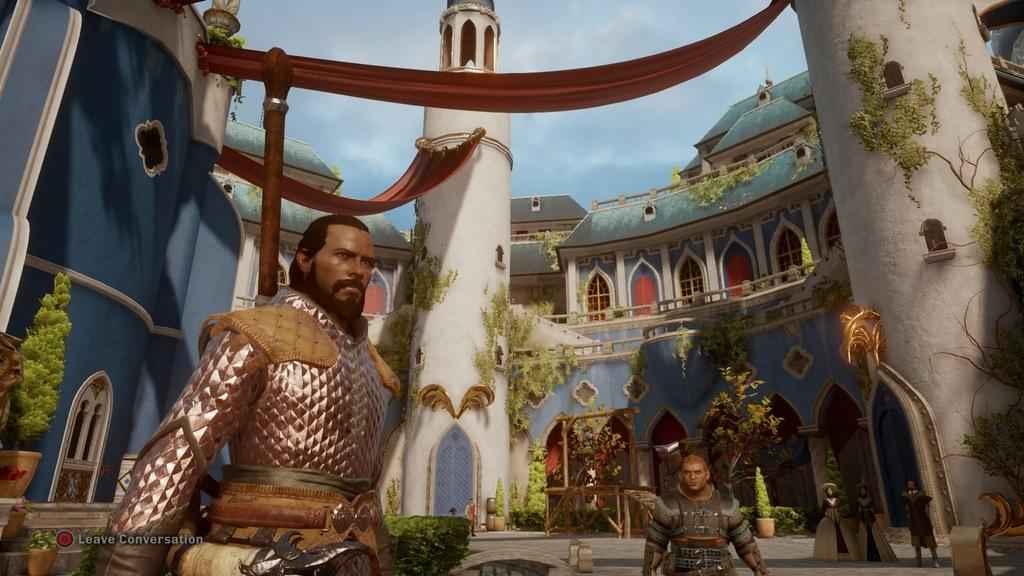What type of scene is depicted in the image? The image contains an animated scene. Can you describe the characters in the image? There are people in the image. What type of structure is present in the image? There is a house in the image. What other objects can be seen in the image? There are plant pots in the image. What type of beast is attacking the house in the image? There is no beast present in the image, nor is there any indication of an attack on the house. 